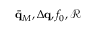<formula> <loc_0><loc_0><loc_500><loc_500>\bar { \mathbf q } _ { M } , \Delta \mathbf q , f _ { 0 } , \mathcal { R }</formula> 